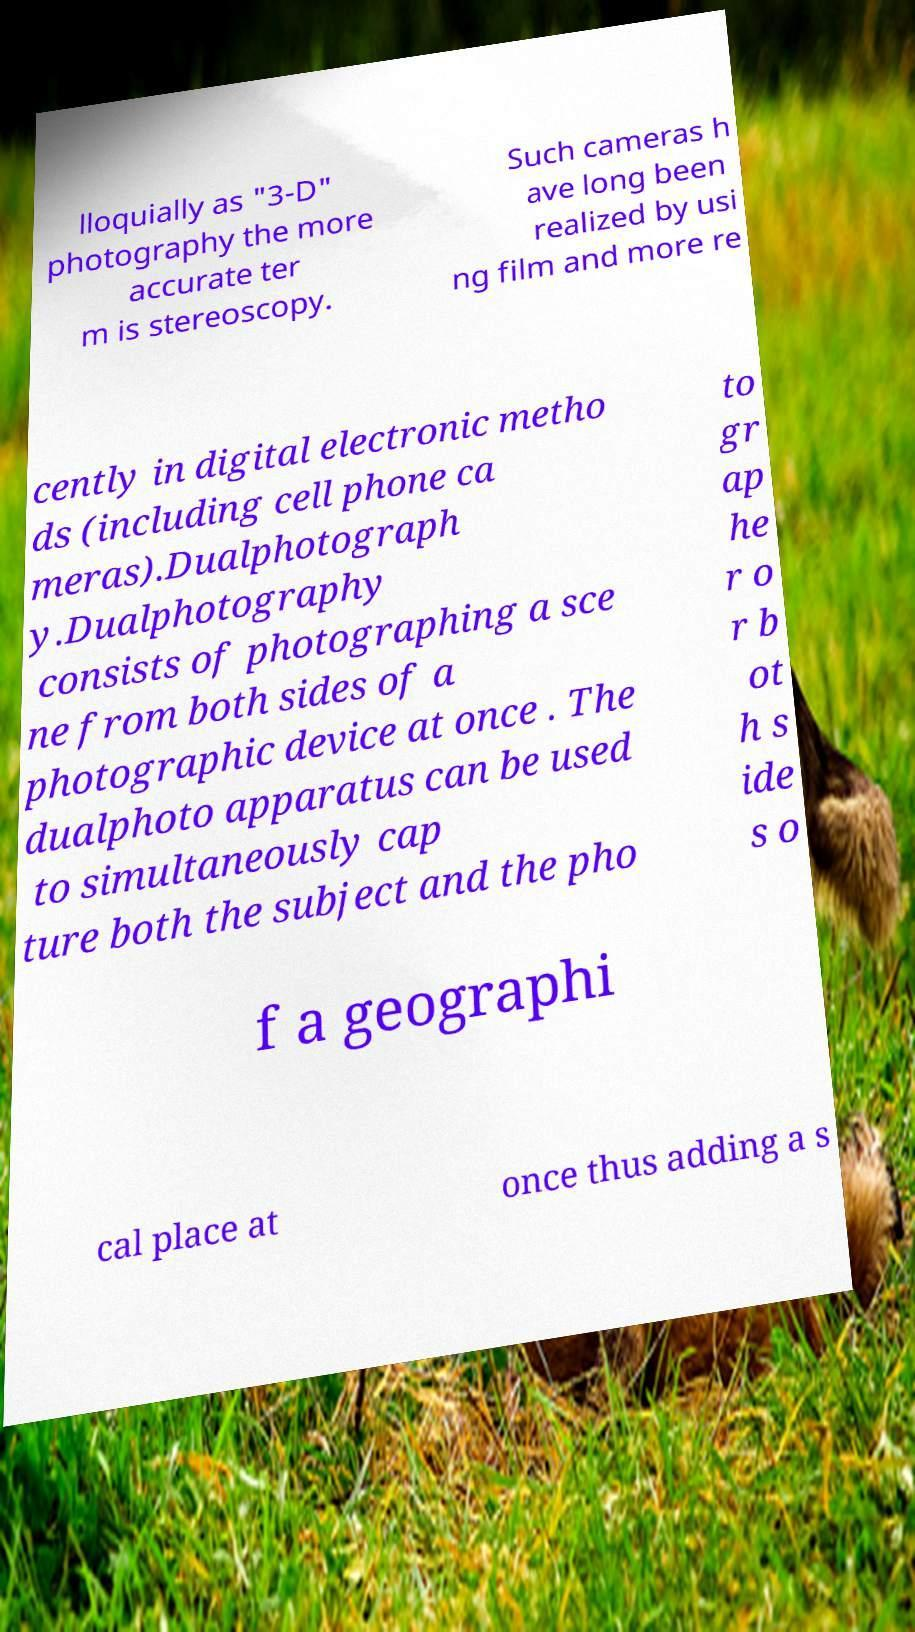Can you accurately transcribe the text from the provided image for me? lloquially as "3-D" photography the more accurate ter m is stereoscopy. Such cameras h ave long been realized by usi ng film and more re cently in digital electronic metho ds (including cell phone ca meras).Dualphotograph y.Dualphotography consists of photographing a sce ne from both sides of a photographic device at once . The dualphoto apparatus can be used to simultaneously cap ture both the subject and the pho to gr ap he r o r b ot h s ide s o f a geographi cal place at once thus adding a s 